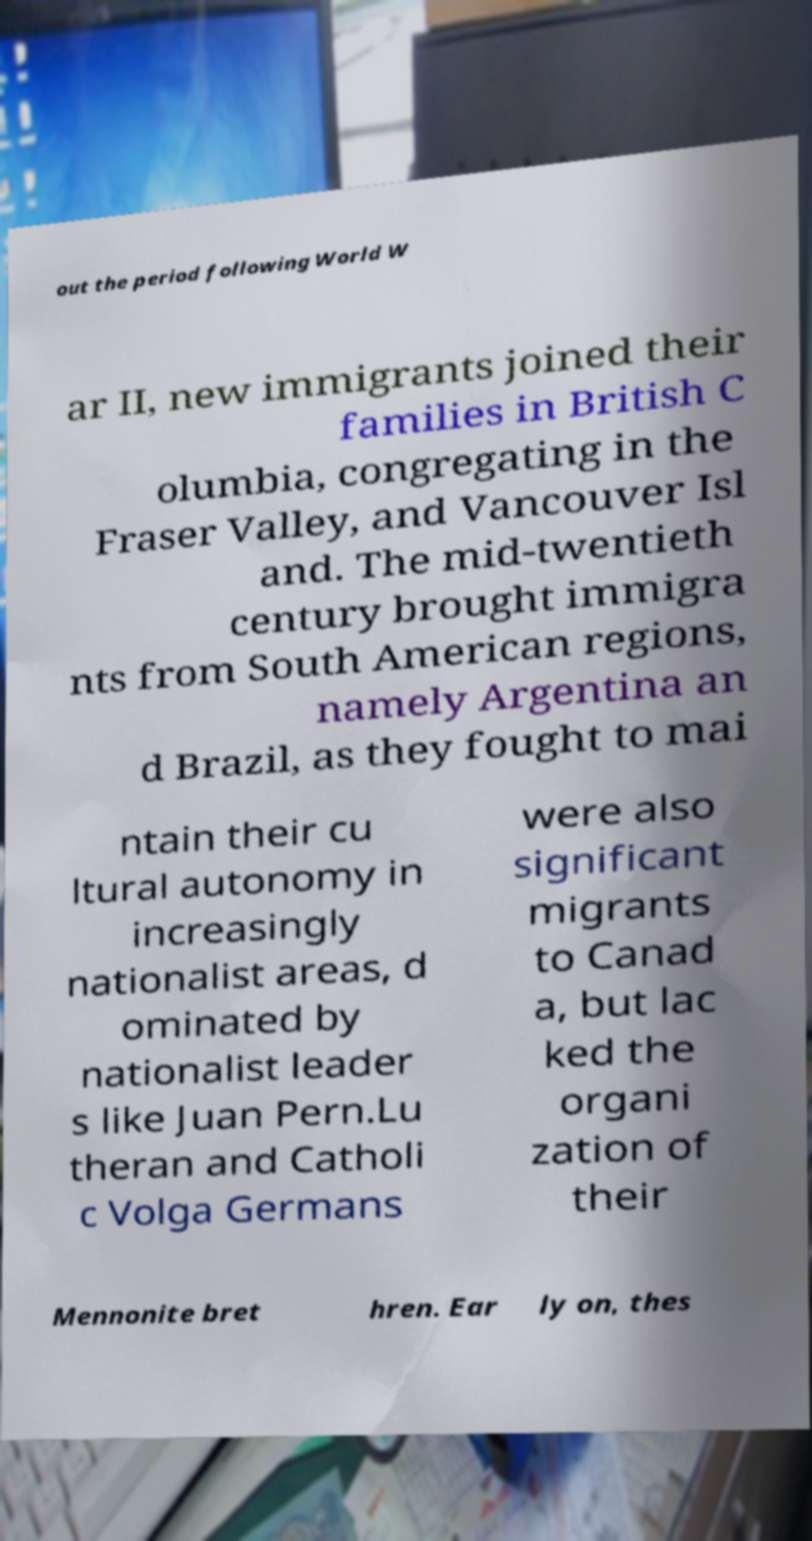Please identify and transcribe the text found in this image. out the period following World W ar II, new immigrants joined their families in British C olumbia, congregating in the Fraser Valley, and Vancouver Isl and. The mid-twentieth century brought immigra nts from South American regions, namely Argentina an d Brazil, as they fought to mai ntain their cu ltural autonomy in increasingly nationalist areas, d ominated by nationalist leader s like Juan Pern.Lu theran and Catholi c Volga Germans were also significant migrants to Canad a, but lac ked the organi zation of their Mennonite bret hren. Ear ly on, thes 